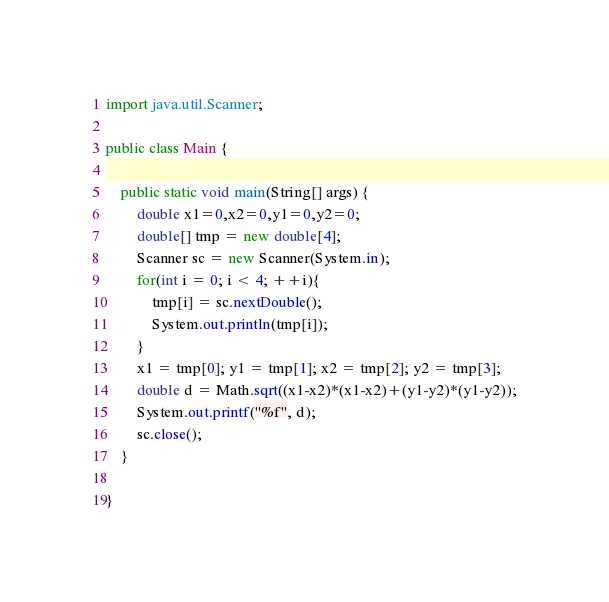<code> <loc_0><loc_0><loc_500><loc_500><_Java_>import java.util.Scanner;

public class Main {

	public static void main(String[] args) {
		double x1=0,x2=0,y1=0,y2=0;
		double[] tmp = new double[4];
		Scanner sc = new Scanner(System.in);
		for(int i = 0; i < 4; ++i){
			tmp[i] = sc.nextDouble();
			System.out.println(tmp[i]);
		}
		x1 = tmp[0]; y1 = tmp[1]; x2 = tmp[2]; y2 = tmp[3];
		double d = Math.sqrt((x1-x2)*(x1-x2)+(y1-y2)*(y1-y2));
		System.out.printf("%f", d);
		sc.close();
	}

}</code> 